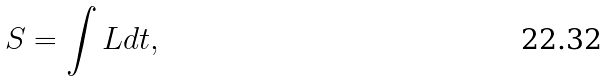Convert formula to latex. <formula><loc_0><loc_0><loc_500><loc_500>S = \int L d t ,</formula> 